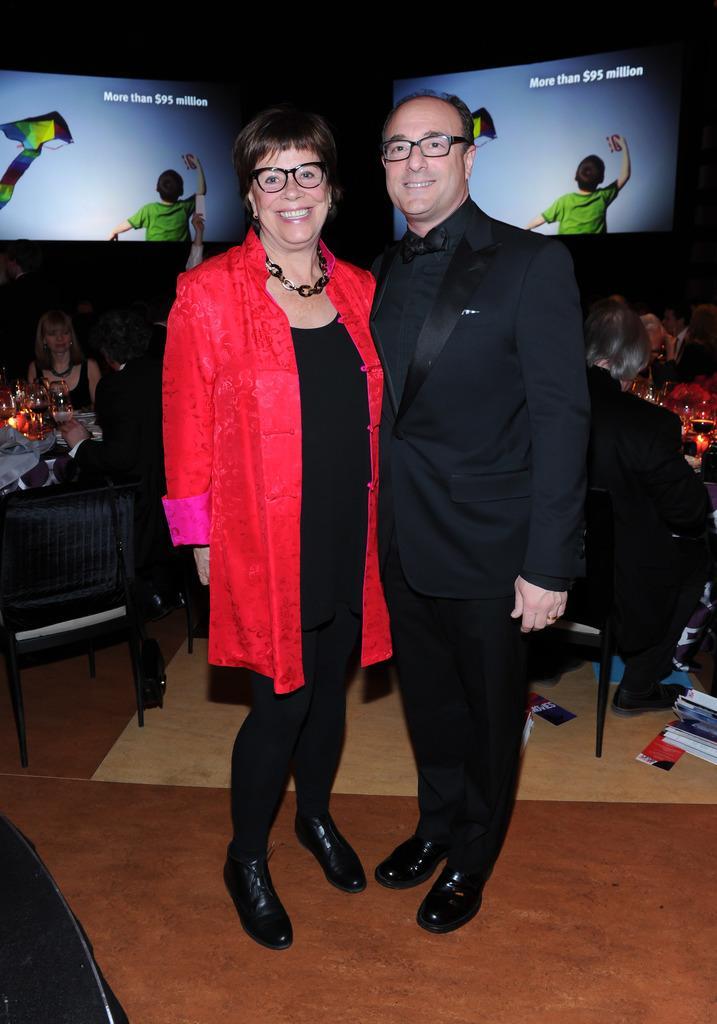Please provide a concise description of this image. In this image I can see a man and a woman are standing and smiling by giving the pose to the picture. In the background I can see two screens and few people are sitting on the chairs. 